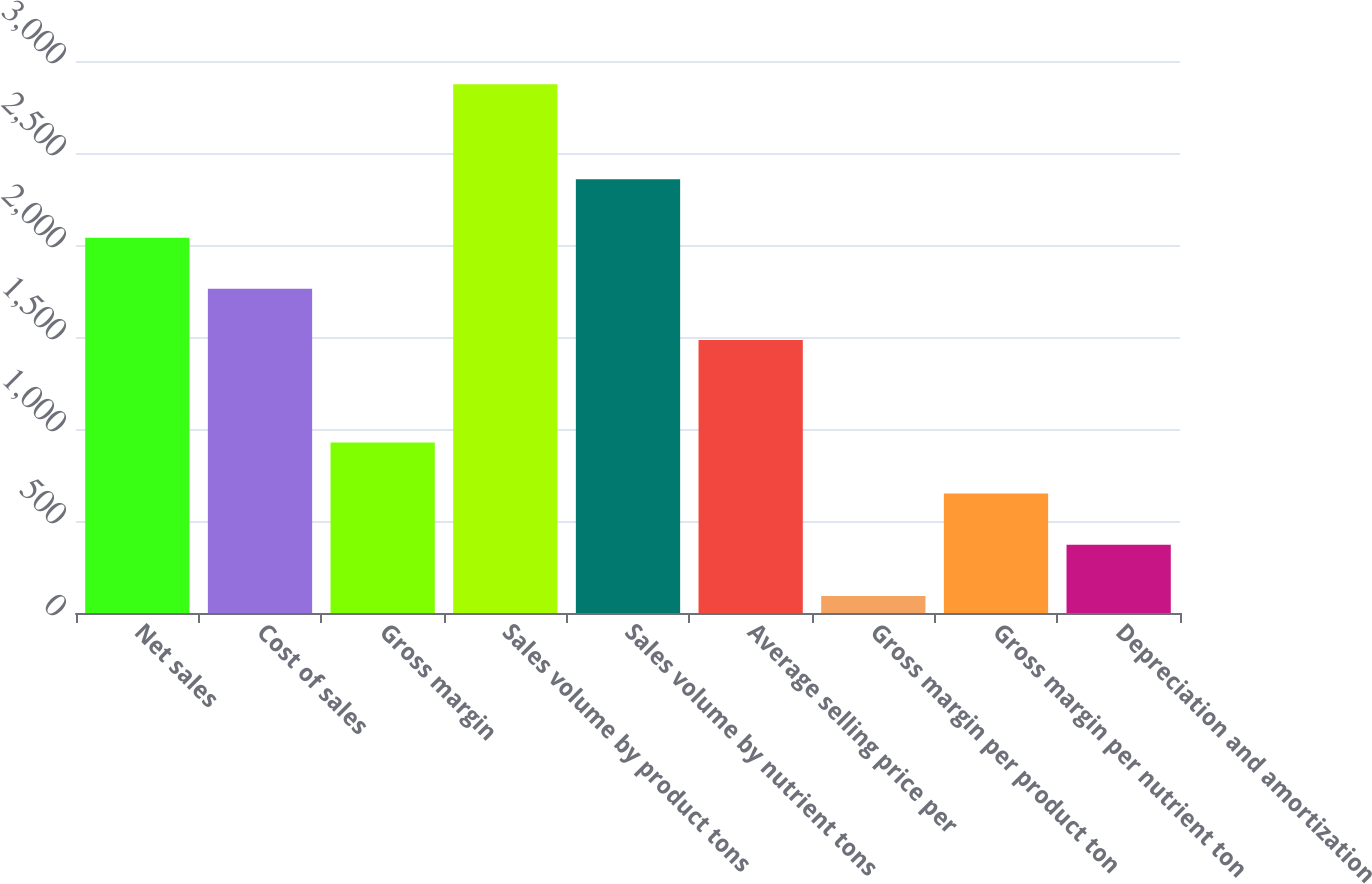Convert chart. <chart><loc_0><loc_0><loc_500><loc_500><bar_chart><fcel>Net sales<fcel>Cost of sales<fcel>Gross margin<fcel>Sales volume by product tons<fcel>Sales volume by nutrient tons<fcel>Average selling price per<fcel>Gross margin per product ton<fcel>Gross margin per nutrient ton<fcel>Depreciation and amortization<nl><fcel>2039.7<fcel>1761.6<fcel>927.3<fcel>2874<fcel>2358<fcel>1483.5<fcel>93<fcel>649.2<fcel>371.1<nl></chart> 